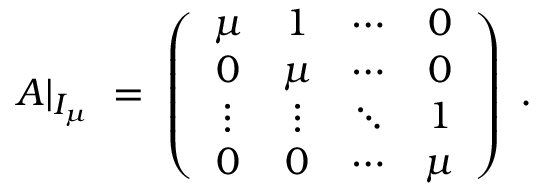<formula> <loc_0><loc_0><loc_500><loc_500>A | _ { I _ { \mu } } \, = \, \left ( \begin{array} { c c c c } { \mu } & { 1 } & { \cdots } & { 0 } \\ { 0 } & { \mu } & { \cdots } & { 0 } \\ { \vdots } & { \vdots } & { \ddots } & { 1 } \\ { 0 } & { 0 } & { \cdots } & { \mu } \end{array} \right ) \, .</formula> 